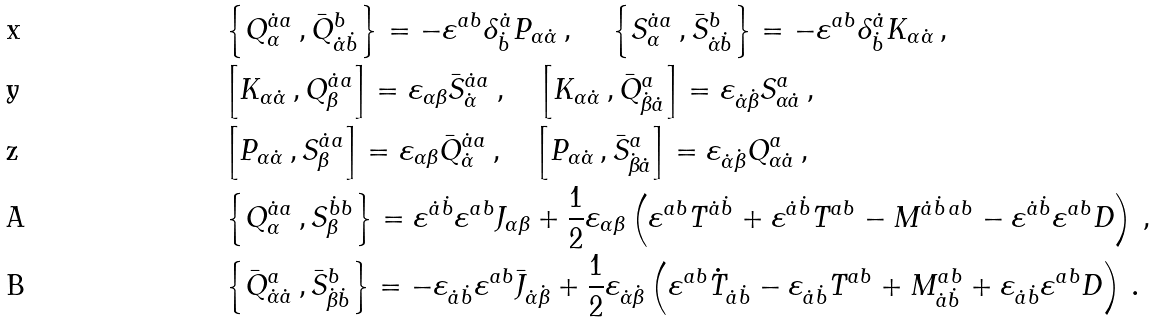Convert formula to latex. <formula><loc_0><loc_0><loc_500><loc_500>& \Big { \{ } Q ^ { \dot { a } a } _ { \alpha } \, , \bar { Q } ^ { b } _ { \dot { \alpha } \dot { b } } \Big { \} } = - \varepsilon ^ { a b } \delta ^ { \dot { a } } _ { \dot { b } } P _ { \alpha \dot { \alpha } } \, , \quad \, \Big { \{ } S ^ { \dot { a } a } _ { \alpha } \, , \bar { S } ^ { b } _ { \dot { \alpha } \dot { b } } \Big { \} } = - \varepsilon ^ { a b } \delta ^ { \dot { a } } _ { \dot { b } } K _ { \alpha \dot { \alpha } } \, , \\ & \Big { [ } K _ { \alpha \dot { \alpha } } \, , Q ^ { \dot { a } a } _ { \beta } \Big { ] } = \varepsilon _ { \alpha \beta } \bar { S } ^ { \dot { a } a } _ { \dot { \alpha } } \, , \quad \Big { [ } K _ { \alpha \dot { \alpha } } \, , \bar { Q } ^ { a } _ { \dot { \beta } \dot { a } } \Big { ] } = \varepsilon _ { \dot { \alpha } \dot { \beta } } S ^ { a } _ { \alpha \dot { a } } \, , \\ & \Big { [ } P _ { \alpha \dot { \alpha } } \, , S ^ { \dot { a } a } _ { \beta } \Big { ] } = \varepsilon _ { \alpha \beta } \bar { Q } ^ { \dot { a } a } _ { \dot { \alpha } } \, , \quad \Big { [ } P _ { \alpha \dot { \alpha } } \, , \bar { S } ^ { a } _ { \dot { \beta } \dot { a } } \Big { ] } = \varepsilon _ { \dot { \alpha } \dot { \beta } } Q ^ { a } _ { \alpha \dot { a } } \, , \\ & \Big { \{ } Q ^ { \dot { a } a } _ { \alpha } \, , S ^ { \dot { b } b } _ { \beta } \Big { \} } = \varepsilon ^ { \dot { a } \dot { b } } \varepsilon ^ { a b } J _ { \alpha \beta } + \frac { 1 } { 2 } \varepsilon _ { \alpha \beta } \left ( \varepsilon ^ { a b } T ^ { \dot { a } \dot { b } } + \varepsilon ^ { \dot { a } \dot { b } } T ^ { a b } - M ^ { \dot { a } \dot { b } \, a b } - \varepsilon ^ { \dot { a } \dot { b } } \varepsilon ^ { a b } D \right ) \, , \\ & \Big { \{ } \bar { Q } ^ { a } _ { \dot { \alpha } \dot { a } } \, , \bar { S } ^ { b } _ { \dot { \beta } \dot { b } } \Big { \} } = - \varepsilon _ { \dot { a } \dot { b } } \varepsilon ^ { a b } \bar { J } _ { \dot { \alpha } \dot { \beta } } + \frac { 1 } { 2 } \varepsilon _ { \dot { \alpha } \dot { \beta } } \left ( \varepsilon ^ { a b } \dot { T } _ { \dot { a } \dot { b } } - \varepsilon _ { \dot { a } \dot { b } } T ^ { a b } + M ^ { a b } _ { \dot { a } \dot { b } } + \varepsilon _ { \dot { a } \dot { b } } \varepsilon ^ { a b } D \right ) \, .</formula> 